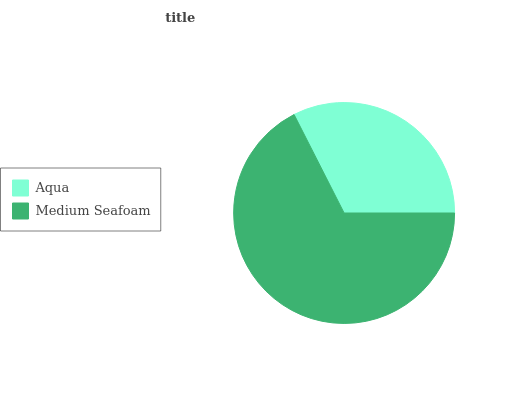Is Aqua the minimum?
Answer yes or no. Yes. Is Medium Seafoam the maximum?
Answer yes or no. Yes. Is Medium Seafoam the minimum?
Answer yes or no. No. Is Medium Seafoam greater than Aqua?
Answer yes or no. Yes. Is Aqua less than Medium Seafoam?
Answer yes or no. Yes. Is Aqua greater than Medium Seafoam?
Answer yes or no. No. Is Medium Seafoam less than Aqua?
Answer yes or no. No. Is Medium Seafoam the high median?
Answer yes or no. Yes. Is Aqua the low median?
Answer yes or no. Yes. Is Aqua the high median?
Answer yes or no. No. Is Medium Seafoam the low median?
Answer yes or no. No. 